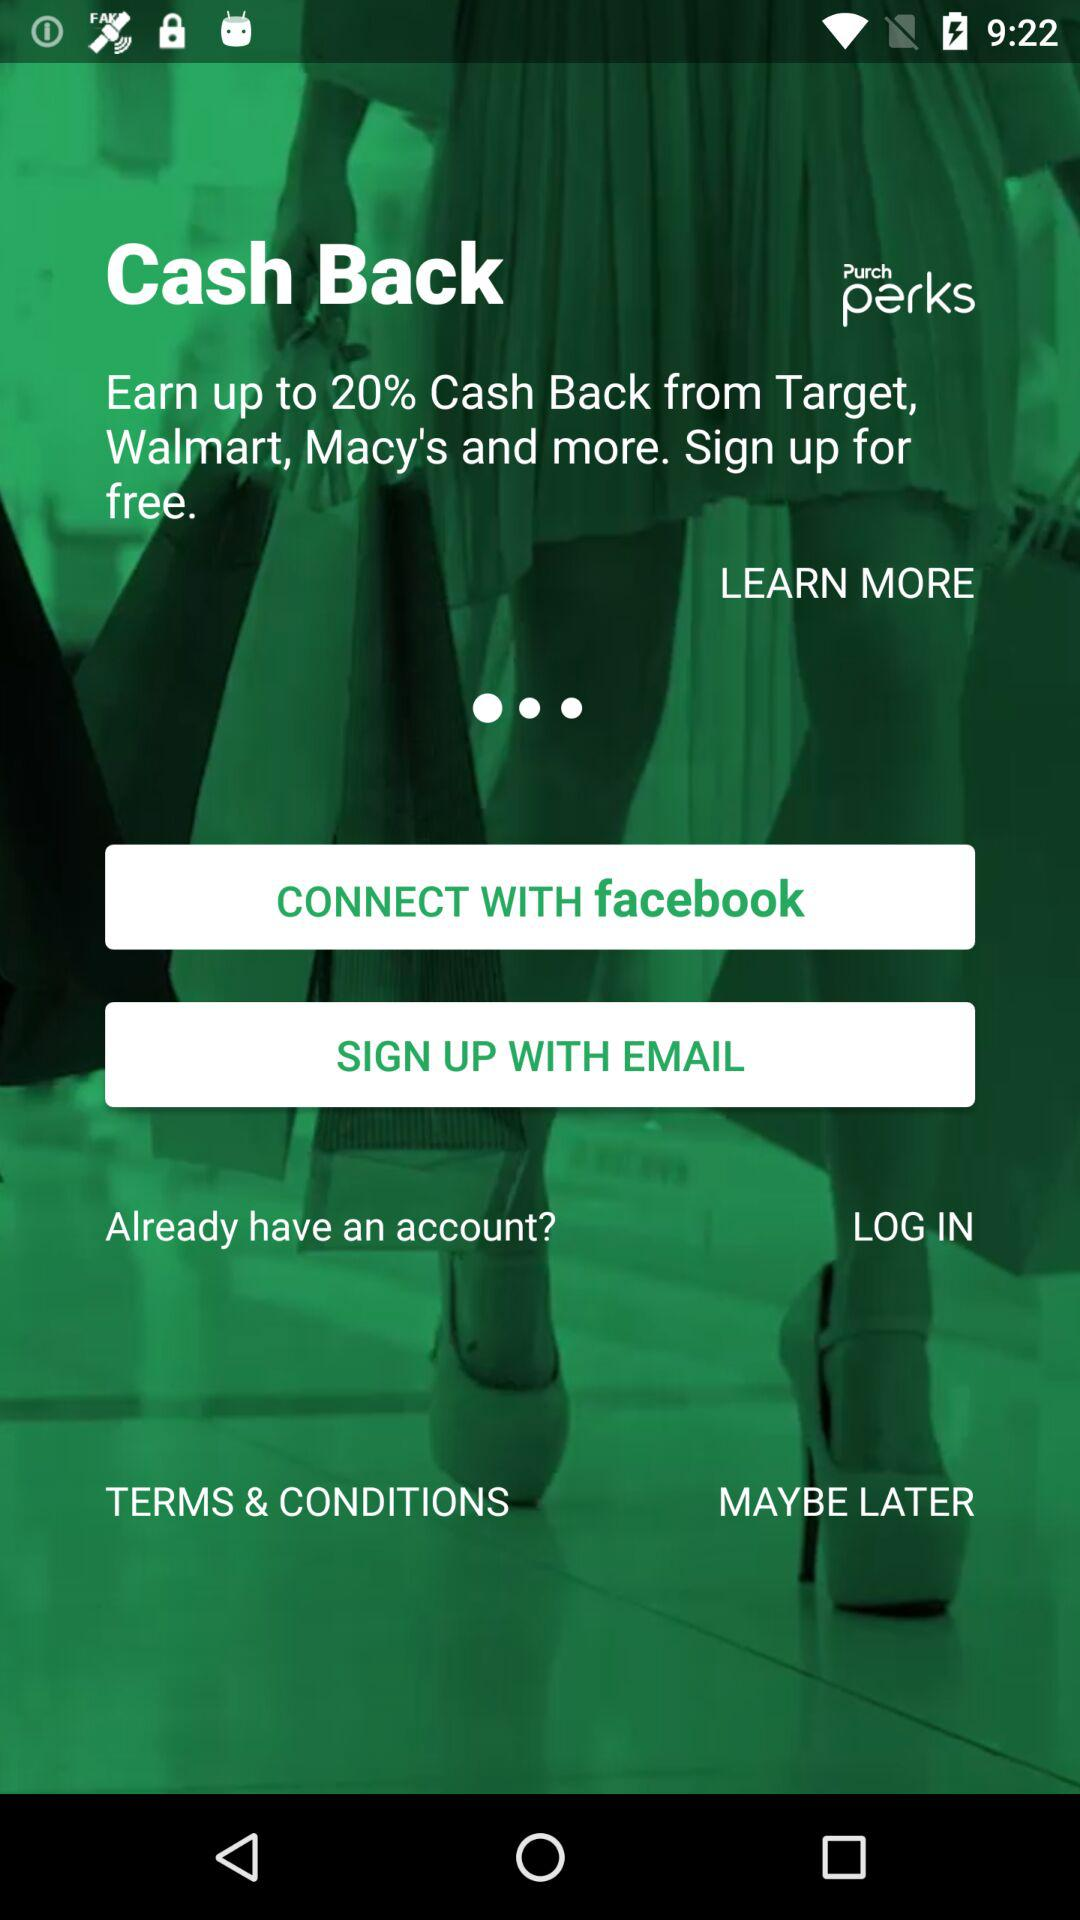Through what option can we sign up? You can sign up through "EMAIL". 